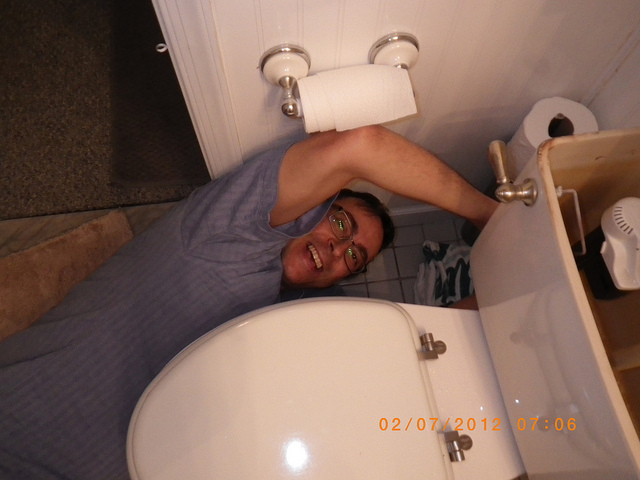Identify and read out the text in this image. 02 07 2012 07 06 